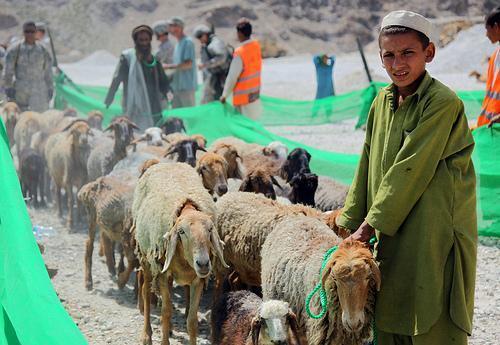How many people in orange vests?
Give a very brief answer. 2. 